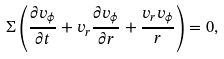<formula> <loc_0><loc_0><loc_500><loc_500>\Sigma \left ( \frac { \partial v _ { \phi } } { \partial t } + v _ { r } \frac { \partial v _ { \phi } } { \partial r } + \frac { v _ { r } v _ { \phi } } { r } \right ) = 0 ,</formula> 